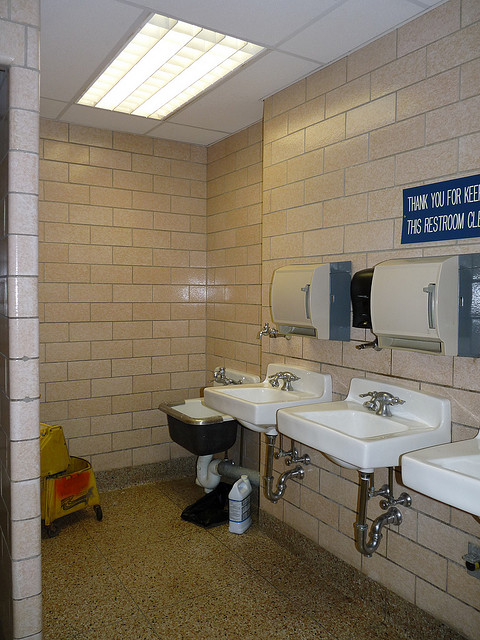Is the skylight so that users can tan themselves? No, the skylight is meant to provide natural light to the restroom, enhancing visibility and energy efficiency, not for tanning purposes. 